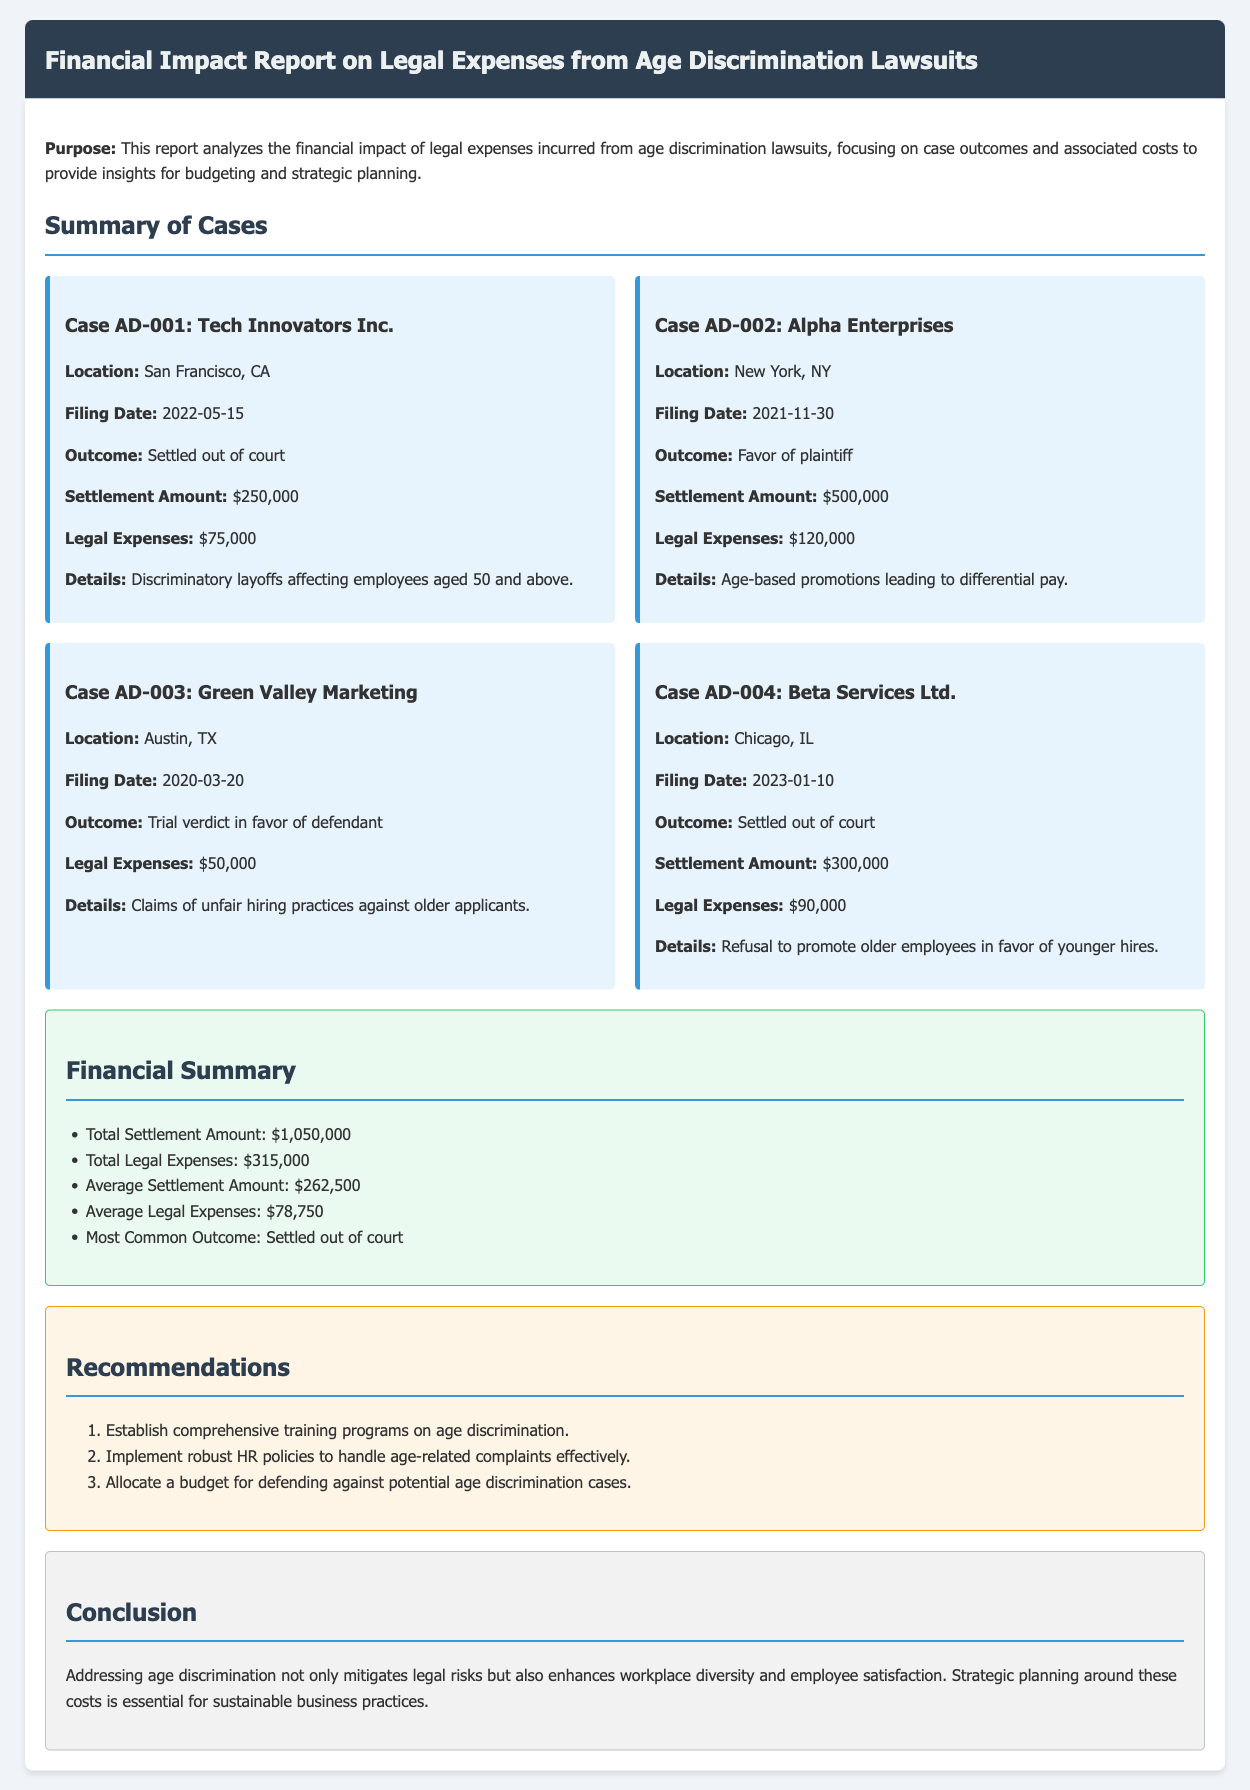What is the filing date of Case AD-001? The filing date for Case AD-001 is specified in the document, which is 2022-05-15.
Answer: 2022-05-15 What was the settlement amount for Alpha Enterprises? The settlement amount for Alpha Enterprises is stated in the report as $500,000.
Answer: $500,000 What is the total legal expenses incurred across all cases? The total legal expenses are calculated based on the figures provided for each case, resulting in a sum of $315,000.
Answer: $315,000 Which case had a trial verdict in favor of the defendant? The document mentions that the case with a trial verdict in favor of the defendant is Case AD-003: Green Valley Marketing.
Answer: Case AD-003: Green Valley Marketing What is the average settlement amount? The average settlement amount is derived from the total settlement amount divided by the number of cases, resulting in $262,500.
Answer: $262,500 What recommendation involves HR policies? One of the recommendations relates to implementing robust HR policies to handle age-related complaints effectively.
Answer: Implement robust HR policies What is the most common outcome listed in the report? The most common outcome mentioned across the cases is stated as "Settled out of court."
Answer: Settled out of court What was the legal expense for Case AD-004? The legal expense for Case AD-004 is outlined in the report as $90,000.
Answer: $90,000 Which location is associated with Case AD-002? The location provided for Case AD-002 is New York, NY.
Answer: New York, NY 